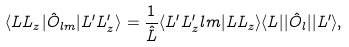Convert formula to latex. <formula><loc_0><loc_0><loc_500><loc_500>\langle L L _ { z } | \hat { O } _ { l m } | L ^ { \prime } L ^ { \prime } _ { z } \rangle = \frac { 1 } { \hat { L } } \langle L ^ { \prime } L ^ { \prime } _ { z } l m | L L _ { z } \rangle \langle L | | \hat { O } _ { l } | | L ^ { \prime } \rangle ,</formula> 